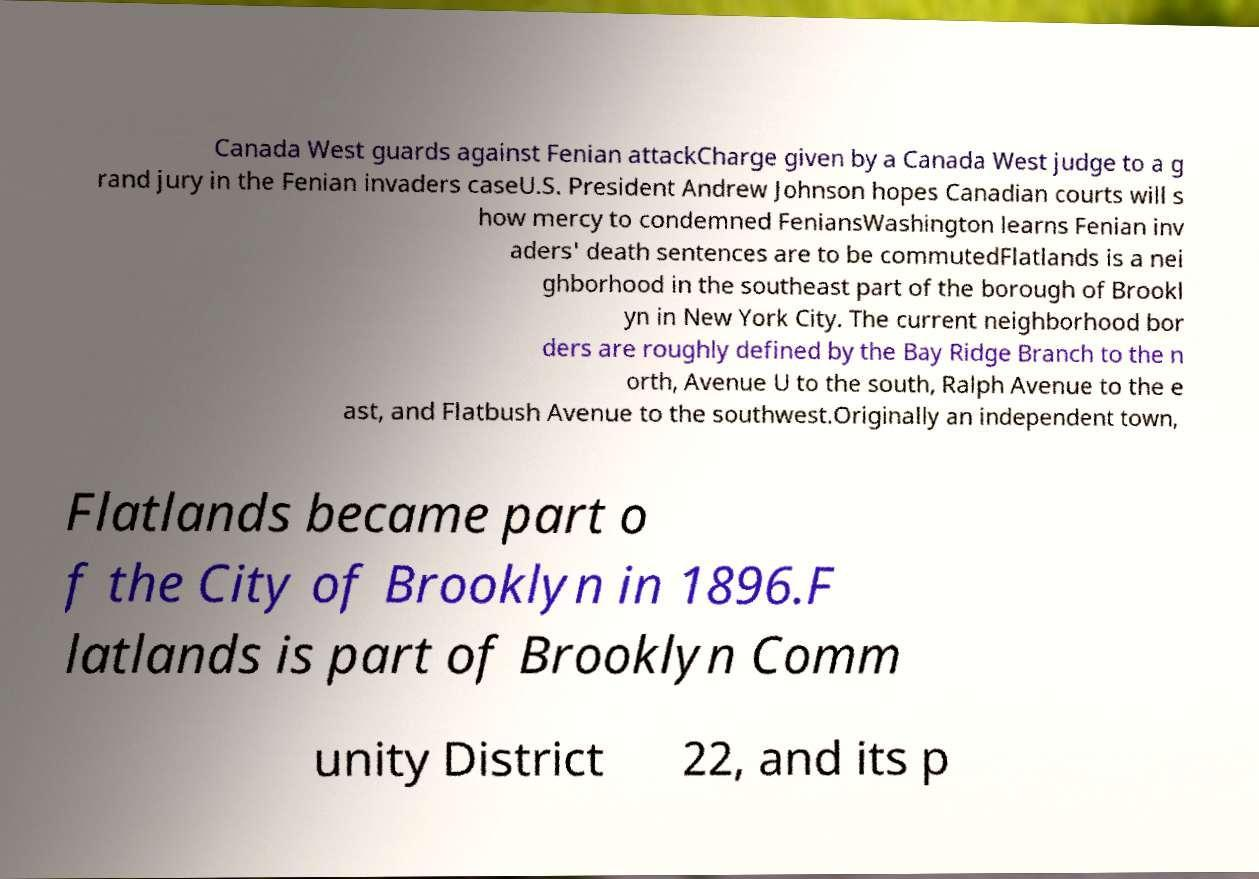What messages or text are displayed in this image? I need them in a readable, typed format. Canada West guards against Fenian attackCharge given by a Canada West judge to a g rand jury in the Fenian invaders caseU.S. President Andrew Johnson hopes Canadian courts will s how mercy to condemned FeniansWashington learns Fenian inv aders' death sentences are to be commutedFlatlands is a nei ghborhood in the southeast part of the borough of Brookl yn in New York City. The current neighborhood bor ders are roughly defined by the Bay Ridge Branch to the n orth, Avenue U to the south, Ralph Avenue to the e ast, and Flatbush Avenue to the southwest.Originally an independent town, Flatlands became part o f the City of Brooklyn in 1896.F latlands is part of Brooklyn Comm unity District 22, and its p 